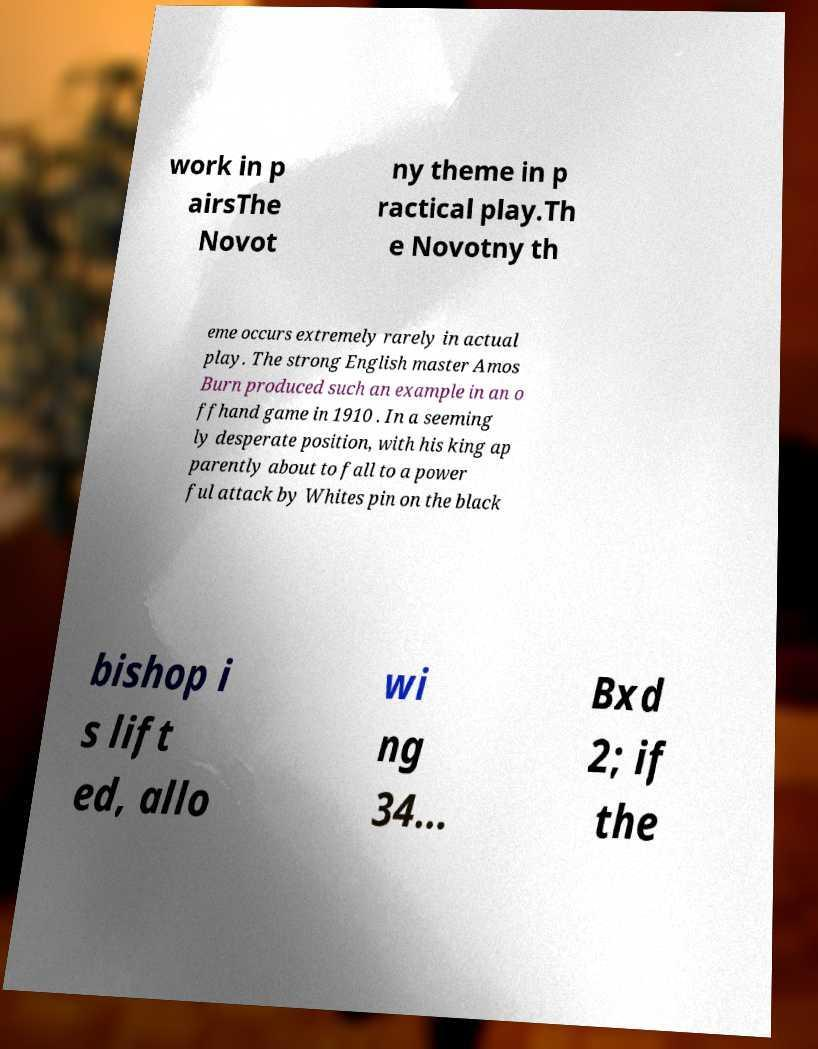Please read and relay the text visible in this image. What does it say? work in p airsThe Novot ny theme in p ractical play.Th e Novotny th eme occurs extremely rarely in actual play. The strong English master Amos Burn produced such an example in an o ffhand game in 1910 . In a seeming ly desperate position, with his king ap parently about to fall to a power ful attack by Whites pin on the black bishop i s lift ed, allo wi ng 34... Bxd 2; if the 